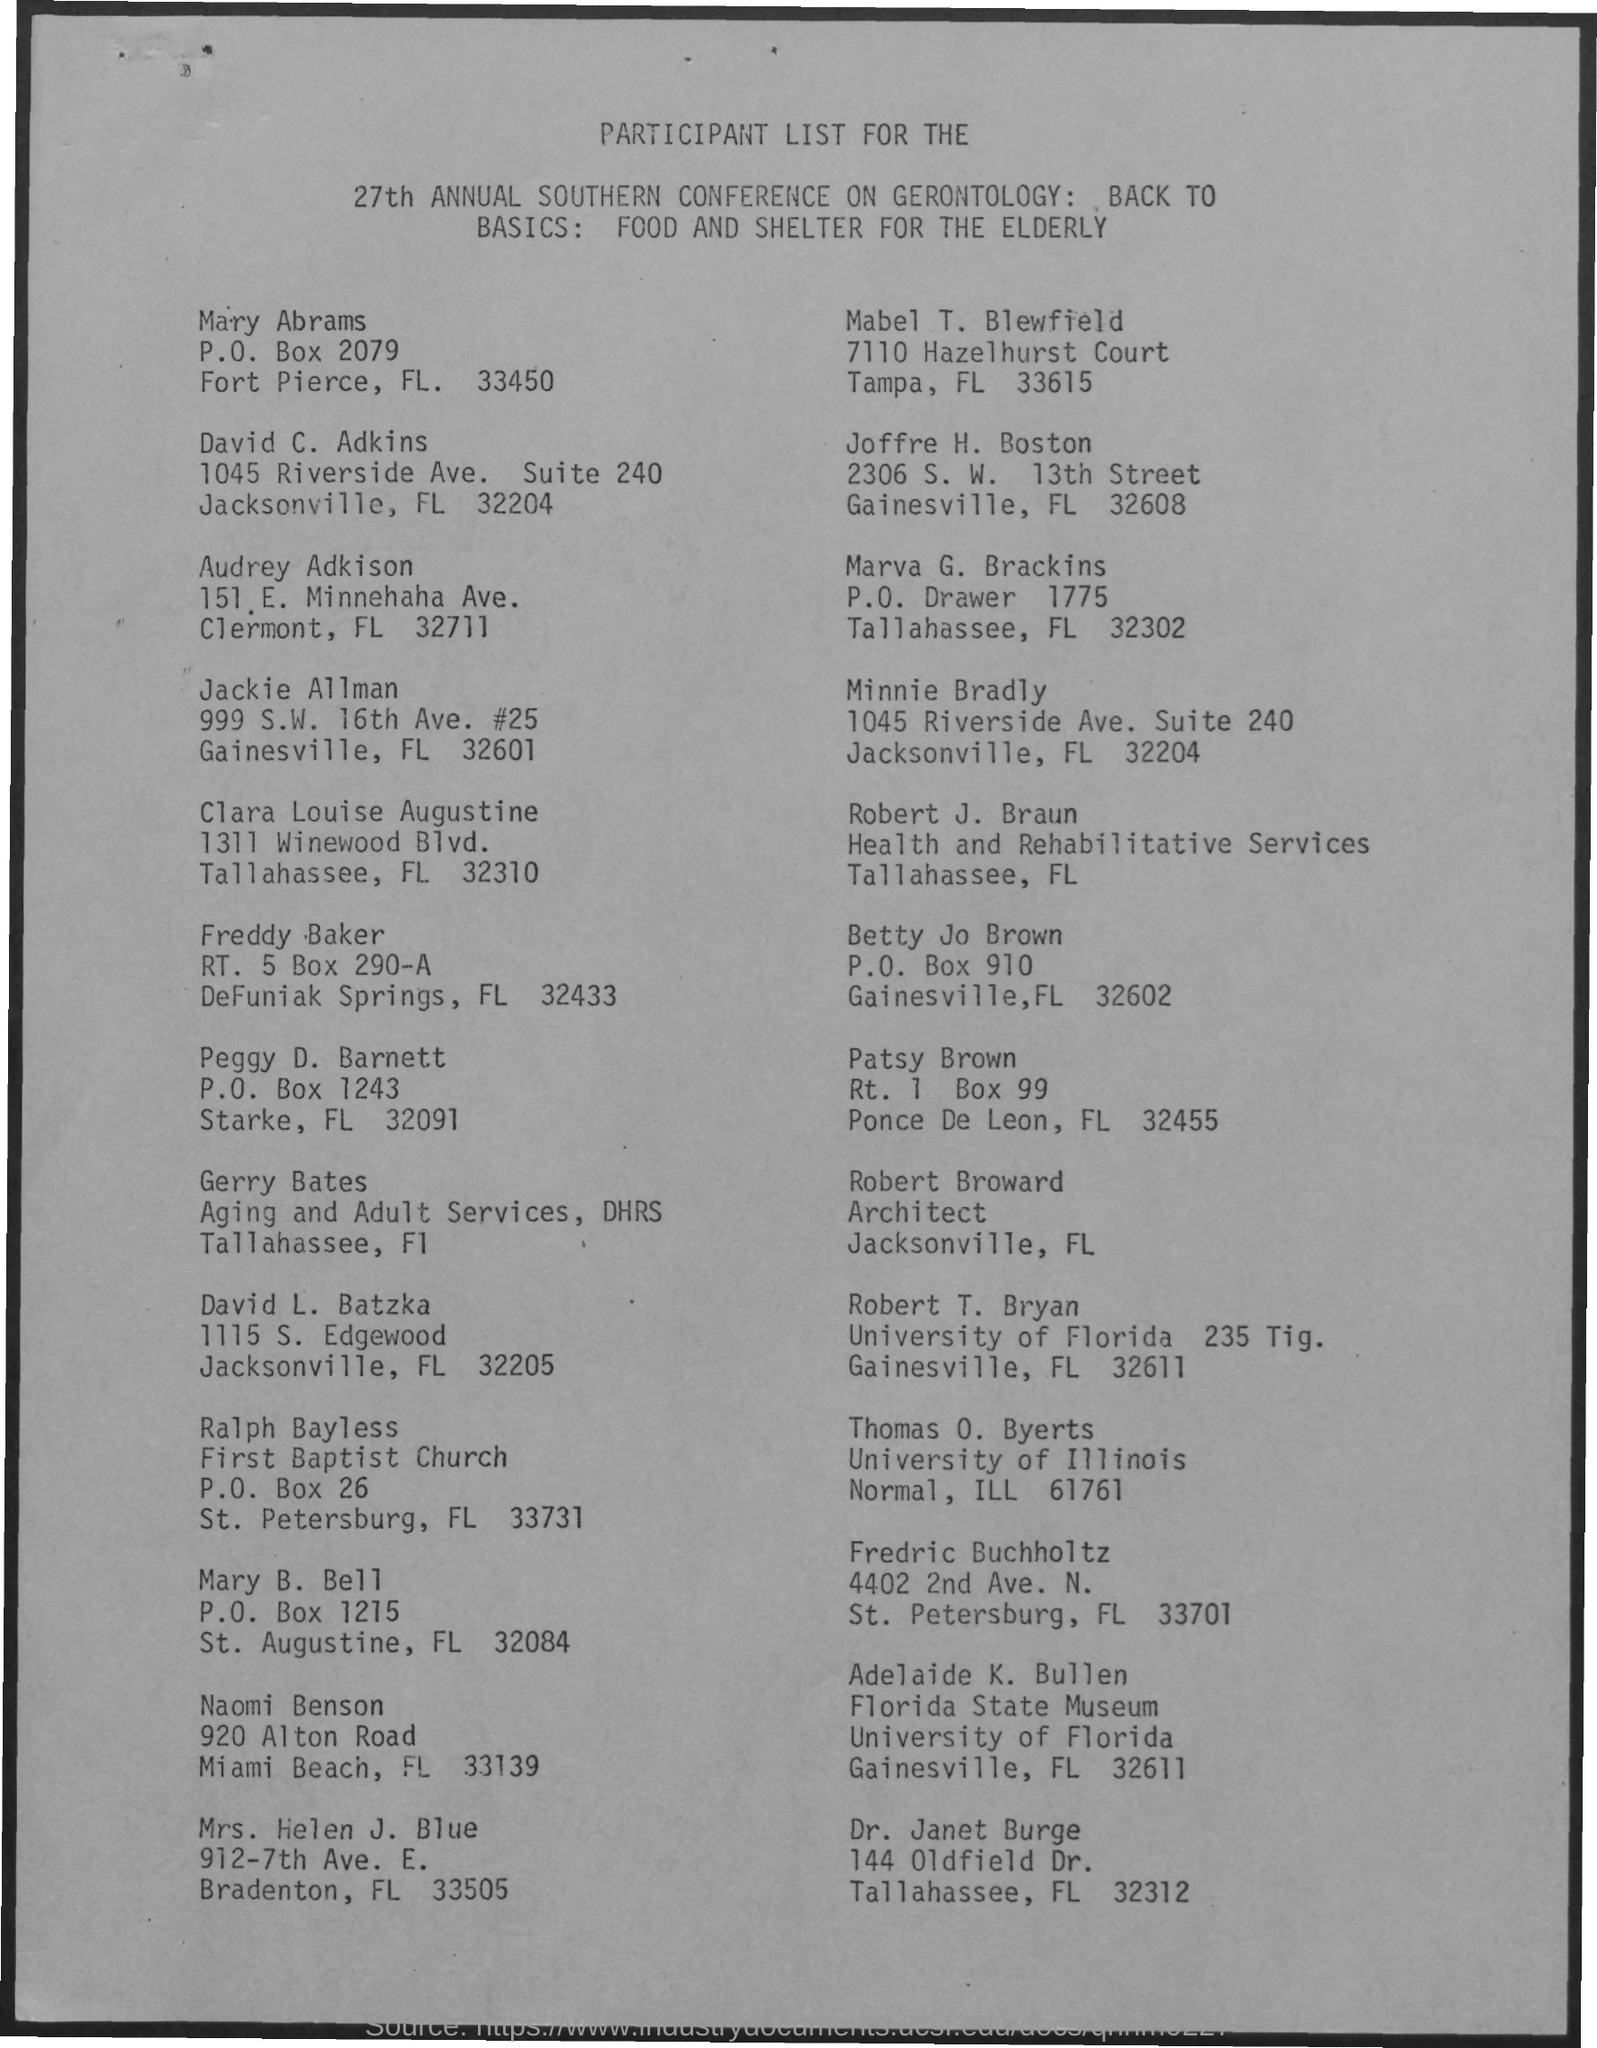What is the designation of Robert Broward?
Offer a very short reply. Architect. 